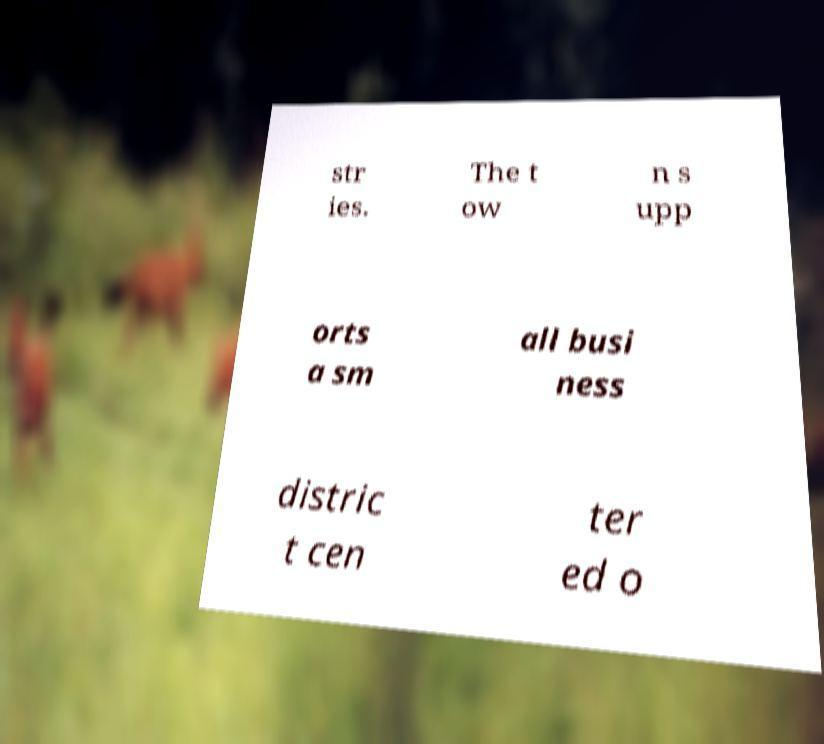For documentation purposes, I need the text within this image transcribed. Could you provide that? str ies. The t ow n s upp orts a sm all busi ness distric t cen ter ed o 